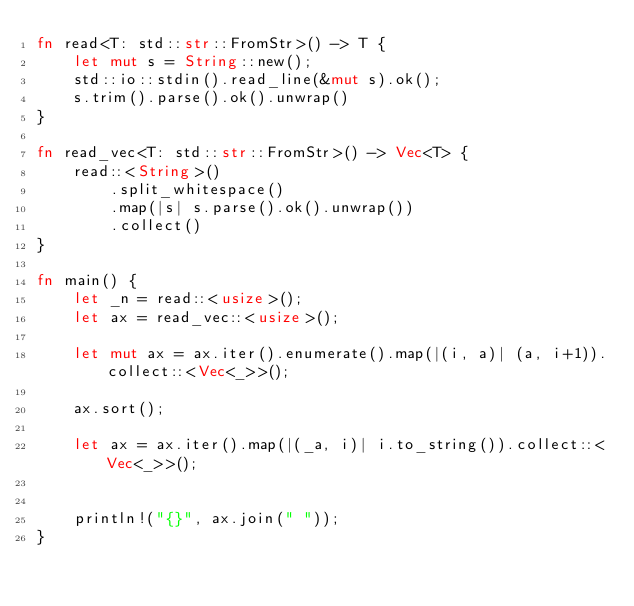Convert code to text. <code><loc_0><loc_0><loc_500><loc_500><_Rust_>fn read<T: std::str::FromStr>() -> T {
    let mut s = String::new();
    std::io::stdin().read_line(&mut s).ok();
    s.trim().parse().ok().unwrap()
}

fn read_vec<T: std::str::FromStr>() -> Vec<T> {
    read::<String>()
        .split_whitespace()
        .map(|s| s.parse().ok().unwrap())
        .collect()
}

fn main() {
    let _n = read::<usize>();
    let ax = read_vec::<usize>();

    let mut ax = ax.iter().enumerate().map(|(i, a)| (a, i+1)).collect::<Vec<_>>();

    ax.sort();

    let ax = ax.iter().map(|(_a, i)| i.to_string()).collect::<Vec<_>>();

 
    println!("{}", ax.join(" "));
}</code> 